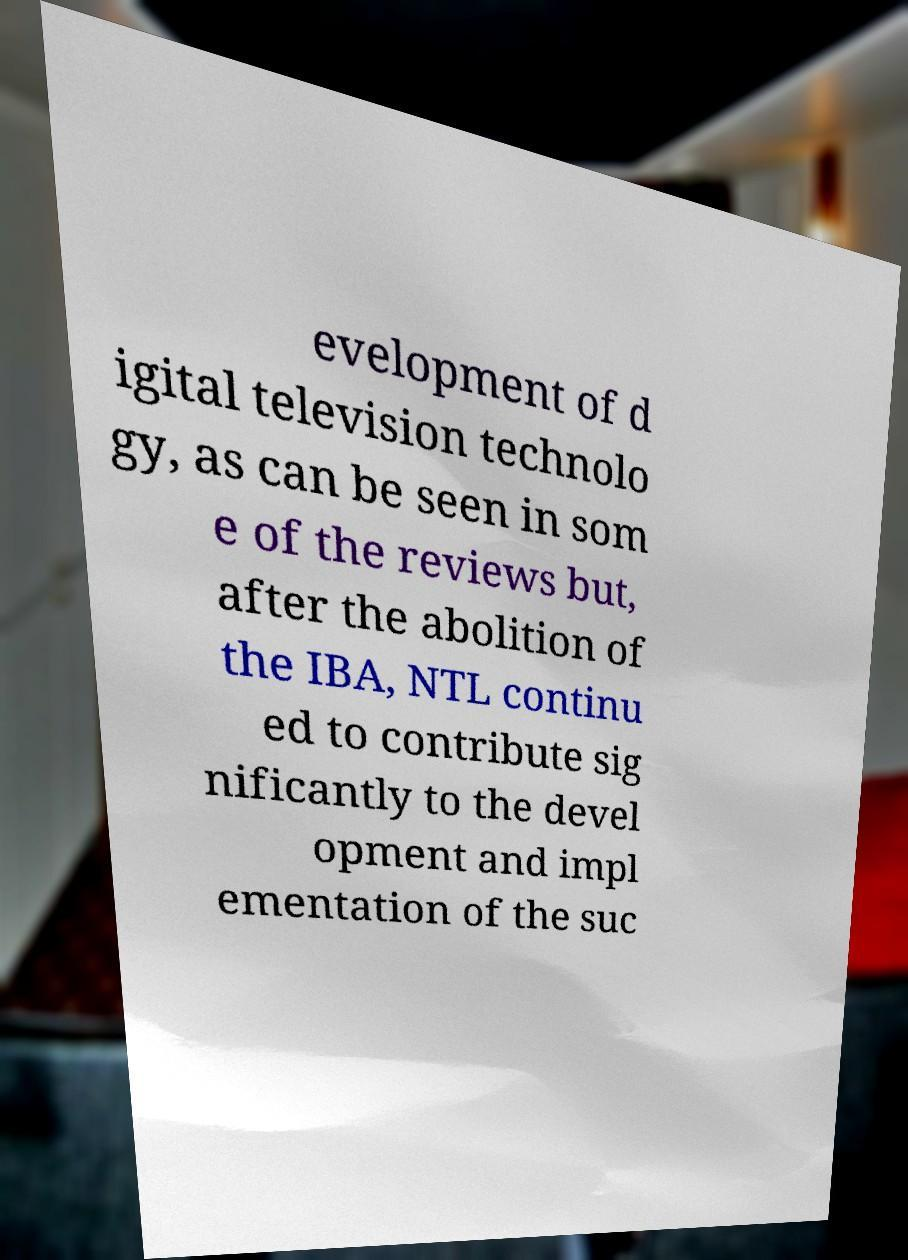What messages or text are displayed in this image? I need them in a readable, typed format. evelopment of d igital television technolo gy, as can be seen in som e of the reviews but, after the abolition of the IBA, NTL continu ed to contribute sig nificantly to the devel opment and impl ementation of the suc 